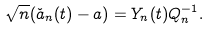Convert formula to latex. <formula><loc_0><loc_0><loc_500><loc_500>\sqrt { n } ( \check { a } _ { n } ( t ) - a ) = Y _ { n } ( t ) Q _ { n } ^ { - 1 } .</formula> 